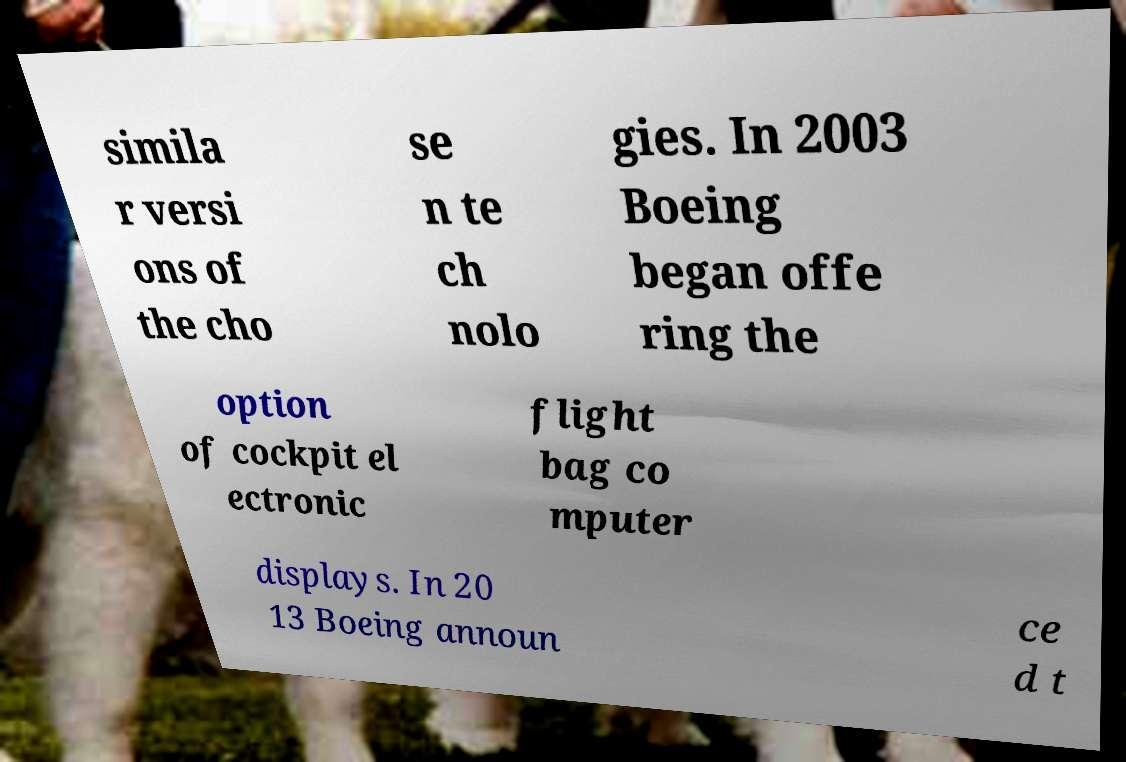Can you accurately transcribe the text from the provided image for me? simila r versi ons of the cho se n te ch nolo gies. In 2003 Boeing began offe ring the option of cockpit el ectronic flight bag co mputer displays. In 20 13 Boeing announ ce d t 